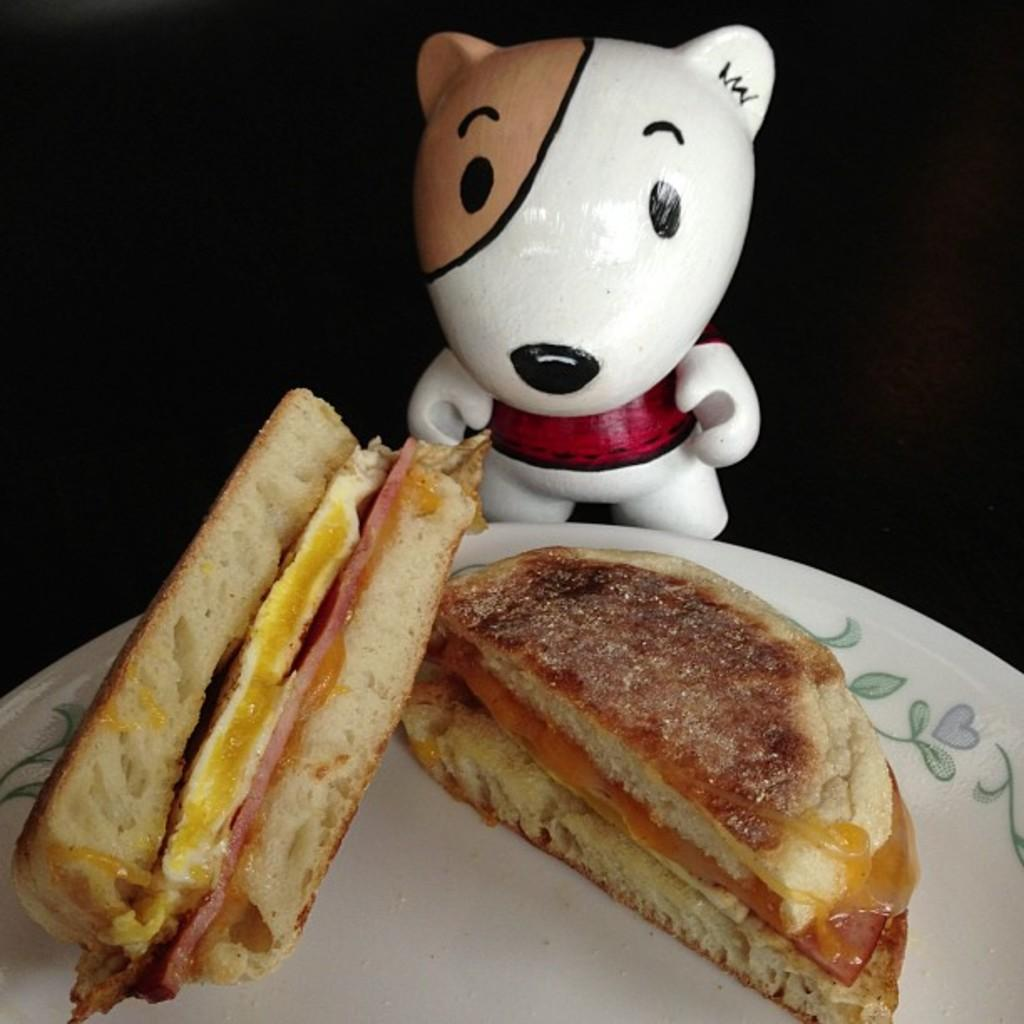What is on the plate in the image? There is food on a plate in the image. What other object can be seen behind the plate? There is a doll behind the plate. How would you describe the overall lighting or color scheme of the image? The backdrop of the image is dark. How many sisters are depicted in the image? There are no sisters depicted in the image. 